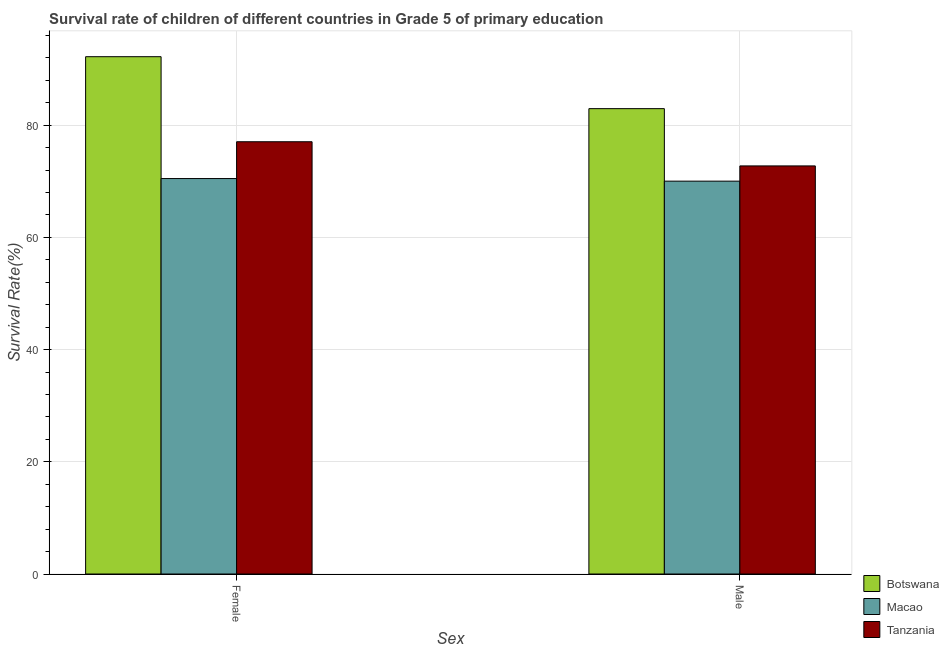How many different coloured bars are there?
Your answer should be very brief. 3. Are the number of bars per tick equal to the number of legend labels?
Your answer should be compact. Yes. Are the number of bars on each tick of the X-axis equal?
Your answer should be compact. Yes. How many bars are there on the 2nd tick from the left?
Your answer should be very brief. 3. How many bars are there on the 2nd tick from the right?
Your response must be concise. 3. What is the survival rate of female students in primary education in Botswana?
Ensure brevity in your answer.  92.22. Across all countries, what is the maximum survival rate of male students in primary education?
Give a very brief answer. 82.96. Across all countries, what is the minimum survival rate of male students in primary education?
Ensure brevity in your answer.  70.03. In which country was the survival rate of female students in primary education maximum?
Ensure brevity in your answer.  Botswana. In which country was the survival rate of female students in primary education minimum?
Provide a succinct answer. Macao. What is the total survival rate of male students in primary education in the graph?
Offer a very short reply. 225.74. What is the difference between the survival rate of female students in primary education in Macao and that in Botswana?
Offer a very short reply. -21.73. What is the difference between the survival rate of male students in primary education in Botswana and the survival rate of female students in primary education in Tanzania?
Keep it short and to the point. 5.9. What is the average survival rate of male students in primary education per country?
Your response must be concise. 75.25. What is the difference between the survival rate of female students in primary education and survival rate of male students in primary education in Botswana?
Give a very brief answer. 9.26. What is the ratio of the survival rate of female students in primary education in Botswana to that in Macao?
Provide a succinct answer. 1.31. What does the 1st bar from the left in Male represents?
Provide a succinct answer. Botswana. What does the 3rd bar from the right in Female represents?
Give a very brief answer. Botswana. Are all the bars in the graph horizontal?
Provide a succinct answer. No. How many countries are there in the graph?
Your response must be concise. 3. What is the difference between two consecutive major ticks on the Y-axis?
Your answer should be very brief. 20. Does the graph contain any zero values?
Offer a very short reply. No. Does the graph contain grids?
Your answer should be compact. Yes. How many legend labels are there?
Make the answer very short. 3. How are the legend labels stacked?
Provide a succinct answer. Vertical. What is the title of the graph?
Offer a very short reply. Survival rate of children of different countries in Grade 5 of primary education. Does "New Caledonia" appear as one of the legend labels in the graph?
Offer a very short reply. No. What is the label or title of the X-axis?
Ensure brevity in your answer.  Sex. What is the label or title of the Y-axis?
Give a very brief answer. Survival Rate(%). What is the Survival Rate(%) of Botswana in Female?
Keep it short and to the point. 92.22. What is the Survival Rate(%) in Macao in Female?
Your response must be concise. 70.49. What is the Survival Rate(%) in Tanzania in Female?
Provide a short and direct response. 77.06. What is the Survival Rate(%) of Botswana in Male?
Keep it short and to the point. 82.96. What is the Survival Rate(%) of Macao in Male?
Give a very brief answer. 70.03. What is the Survival Rate(%) in Tanzania in Male?
Keep it short and to the point. 72.75. Across all Sex, what is the maximum Survival Rate(%) of Botswana?
Ensure brevity in your answer.  92.22. Across all Sex, what is the maximum Survival Rate(%) of Macao?
Make the answer very short. 70.49. Across all Sex, what is the maximum Survival Rate(%) in Tanzania?
Provide a short and direct response. 77.06. Across all Sex, what is the minimum Survival Rate(%) in Botswana?
Your answer should be compact. 82.96. Across all Sex, what is the minimum Survival Rate(%) of Macao?
Your response must be concise. 70.03. Across all Sex, what is the minimum Survival Rate(%) in Tanzania?
Offer a terse response. 72.75. What is the total Survival Rate(%) in Botswana in the graph?
Ensure brevity in your answer.  175.18. What is the total Survival Rate(%) of Macao in the graph?
Keep it short and to the point. 140.53. What is the total Survival Rate(%) in Tanzania in the graph?
Give a very brief answer. 149.81. What is the difference between the Survival Rate(%) in Botswana in Female and that in Male?
Give a very brief answer. 9.26. What is the difference between the Survival Rate(%) in Macao in Female and that in Male?
Your answer should be very brief. 0.46. What is the difference between the Survival Rate(%) in Tanzania in Female and that in Male?
Offer a very short reply. 4.31. What is the difference between the Survival Rate(%) in Botswana in Female and the Survival Rate(%) in Macao in Male?
Keep it short and to the point. 22.19. What is the difference between the Survival Rate(%) of Botswana in Female and the Survival Rate(%) of Tanzania in Male?
Make the answer very short. 19.47. What is the difference between the Survival Rate(%) in Macao in Female and the Survival Rate(%) in Tanzania in Male?
Offer a very short reply. -2.26. What is the average Survival Rate(%) in Botswana per Sex?
Provide a short and direct response. 87.59. What is the average Survival Rate(%) in Macao per Sex?
Keep it short and to the point. 70.26. What is the average Survival Rate(%) of Tanzania per Sex?
Your answer should be compact. 74.9. What is the difference between the Survival Rate(%) of Botswana and Survival Rate(%) of Macao in Female?
Provide a succinct answer. 21.73. What is the difference between the Survival Rate(%) of Botswana and Survival Rate(%) of Tanzania in Female?
Your response must be concise. 15.16. What is the difference between the Survival Rate(%) in Macao and Survival Rate(%) in Tanzania in Female?
Keep it short and to the point. -6.56. What is the difference between the Survival Rate(%) of Botswana and Survival Rate(%) of Macao in Male?
Make the answer very short. 12.92. What is the difference between the Survival Rate(%) of Botswana and Survival Rate(%) of Tanzania in Male?
Your answer should be very brief. 10.21. What is the difference between the Survival Rate(%) in Macao and Survival Rate(%) in Tanzania in Male?
Make the answer very short. -2.72. What is the ratio of the Survival Rate(%) of Botswana in Female to that in Male?
Your response must be concise. 1.11. What is the ratio of the Survival Rate(%) of Macao in Female to that in Male?
Make the answer very short. 1.01. What is the ratio of the Survival Rate(%) in Tanzania in Female to that in Male?
Your answer should be compact. 1.06. What is the difference between the highest and the second highest Survival Rate(%) of Botswana?
Your answer should be very brief. 9.26. What is the difference between the highest and the second highest Survival Rate(%) in Macao?
Provide a succinct answer. 0.46. What is the difference between the highest and the second highest Survival Rate(%) of Tanzania?
Keep it short and to the point. 4.31. What is the difference between the highest and the lowest Survival Rate(%) in Botswana?
Your answer should be very brief. 9.26. What is the difference between the highest and the lowest Survival Rate(%) of Macao?
Ensure brevity in your answer.  0.46. What is the difference between the highest and the lowest Survival Rate(%) in Tanzania?
Your response must be concise. 4.31. 